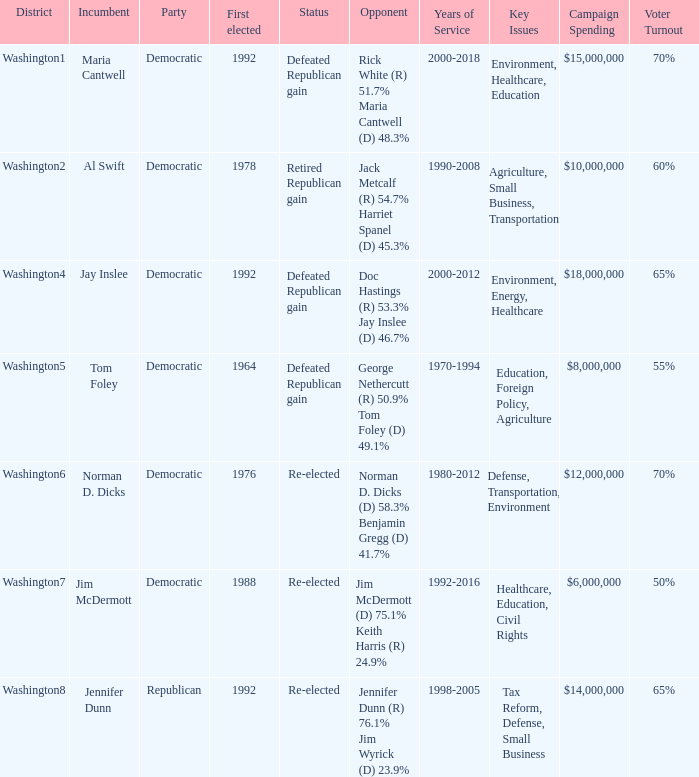When was the first election in which incumbent jim mcdermott won? 1988.0. Write the full table. {'header': ['District', 'Incumbent', 'Party', 'First elected', 'Status', 'Opponent', 'Years of Service', 'Key Issues', 'Campaign Spending', 'Voter Turnout'], 'rows': [['Washington1', 'Maria Cantwell', 'Democratic', '1992', 'Defeated Republican gain', 'Rick White (R) 51.7% Maria Cantwell (D) 48.3%', '2000-2018', 'Environment, Healthcare, Education', '$15,000,000', '70%'], ['Washington2', 'Al Swift', 'Democratic', '1978', 'Retired Republican gain', 'Jack Metcalf (R) 54.7% Harriet Spanel (D) 45.3%', '1990-2008', 'Agriculture, Small Business, Transportation', '$10,000,000', '60%'], ['Washington4', 'Jay Inslee', 'Democratic', '1992', 'Defeated Republican gain', 'Doc Hastings (R) 53.3% Jay Inslee (D) 46.7%', '2000-2012', 'Environment, Energy, Healthcare', '$18,000,000', '65%'], ['Washington5', 'Tom Foley', 'Democratic', '1964', 'Defeated Republican gain', 'George Nethercutt (R) 50.9% Tom Foley (D) 49.1%', '1970-1994', 'Education, Foreign Policy, Agriculture', '$8,000,000', '55%'], ['Washington6', 'Norman D. Dicks', 'Democratic', '1976', 'Re-elected', 'Norman D. Dicks (D) 58.3% Benjamin Gregg (D) 41.7%', '1980-2012', 'Defense, Transportation, Environment', '$12,000,000', '70%'], ['Washington7', 'Jim McDermott', 'Democratic', '1988', 'Re-elected', 'Jim McDermott (D) 75.1% Keith Harris (R) 24.9%', '1992-2016', 'Healthcare, Education, Civil Rights', '$6,000,000', '50%'], ['Washington8', 'Jennifer Dunn', 'Republican', '1992', 'Re-elected', 'Jennifer Dunn (R) 76.1% Jim Wyrick (D) 23.9%', '1998-2005', 'Tax Reform, Defense, Small Business', '$14,000,000', '65%']]} 